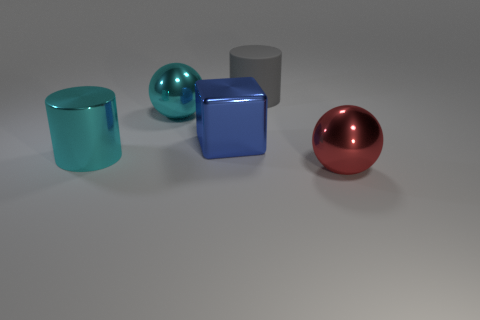Can you describe the setting or environment where these objects are placed? The objects are placed in a neutral environment that resembles a studio setup. The scene is characterized by a soft shadow on the flat surface beneath the objects, indicating diffused lighting often used in photography to enhance the appearance of products. There's no discernible backdrop that indicates a specific location, which focuses attention solely on the objects, their shapes, and material properties. If you had to guess, what purpose might these objects serve? Considering their simple and clean designs, these objects could serve as models for an educational purpose, such as teaching about shapes, reflections, and materials in a visual arts or physics class. Alternatively, they could also be used as design elements in a 3D modeling software demonstration, or as decorative pieces showcasing minimalist aesthetic. 